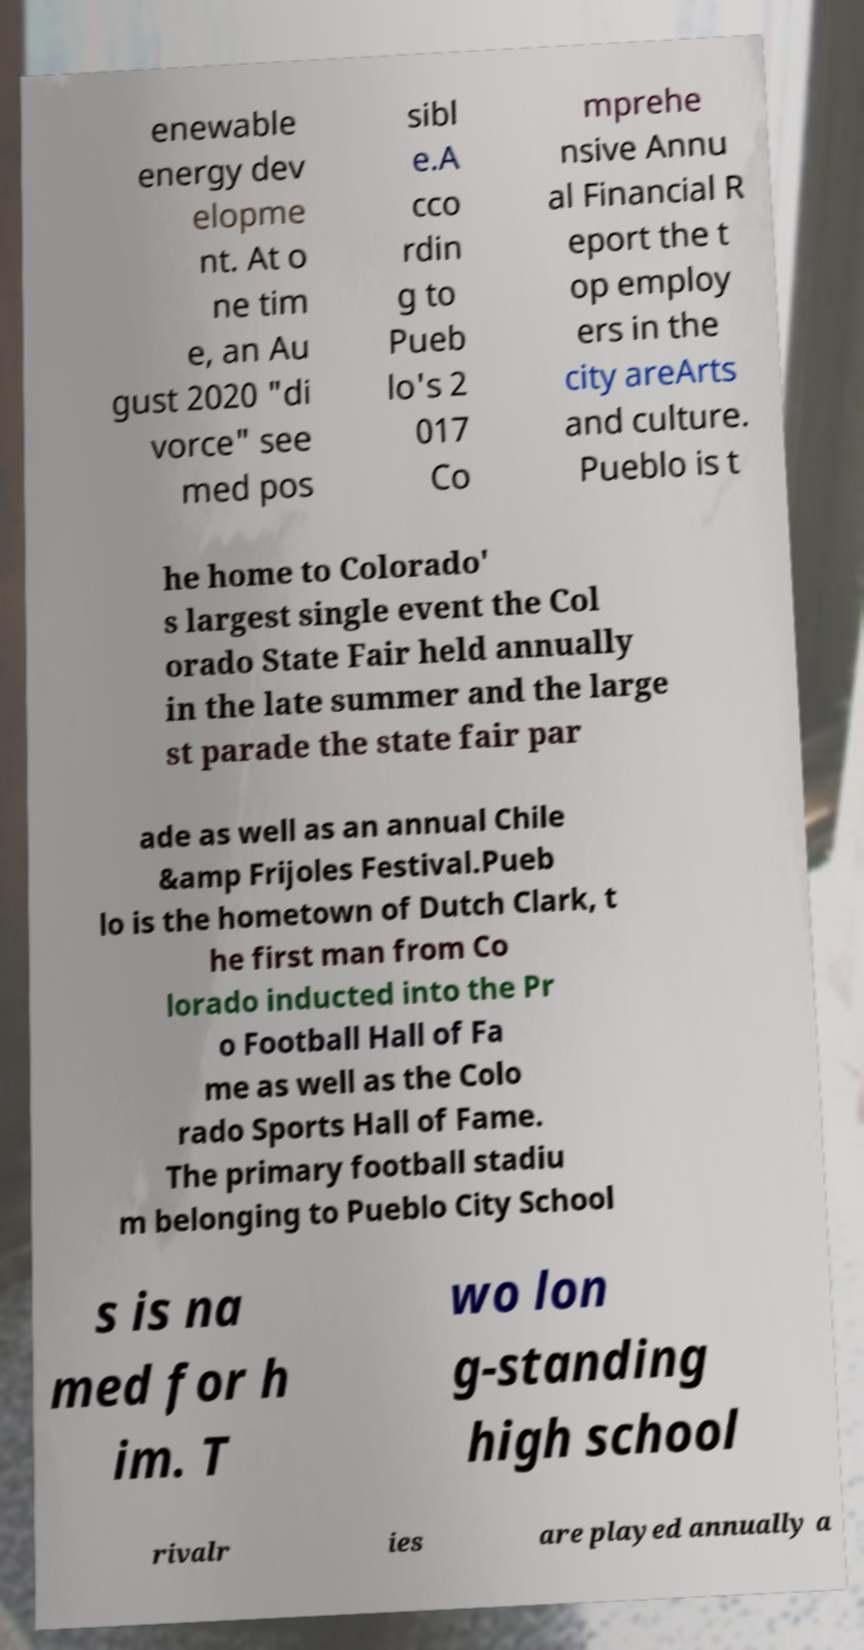Please read and relay the text visible in this image. What does it say? enewable energy dev elopme nt. At o ne tim e, an Au gust 2020 "di vorce" see med pos sibl e.A cco rdin g to Pueb lo's 2 017 Co mprehe nsive Annu al Financial R eport the t op employ ers in the city areArts and culture. Pueblo is t he home to Colorado' s largest single event the Col orado State Fair held annually in the late summer and the large st parade the state fair par ade as well as an annual Chile &amp Frijoles Festival.Pueb lo is the hometown of Dutch Clark, t he first man from Co lorado inducted into the Pr o Football Hall of Fa me as well as the Colo rado Sports Hall of Fame. The primary football stadiu m belonging to Pueblo City School s is na med for h im. T wo lon g-standing high school rivalr ies are played annually a 